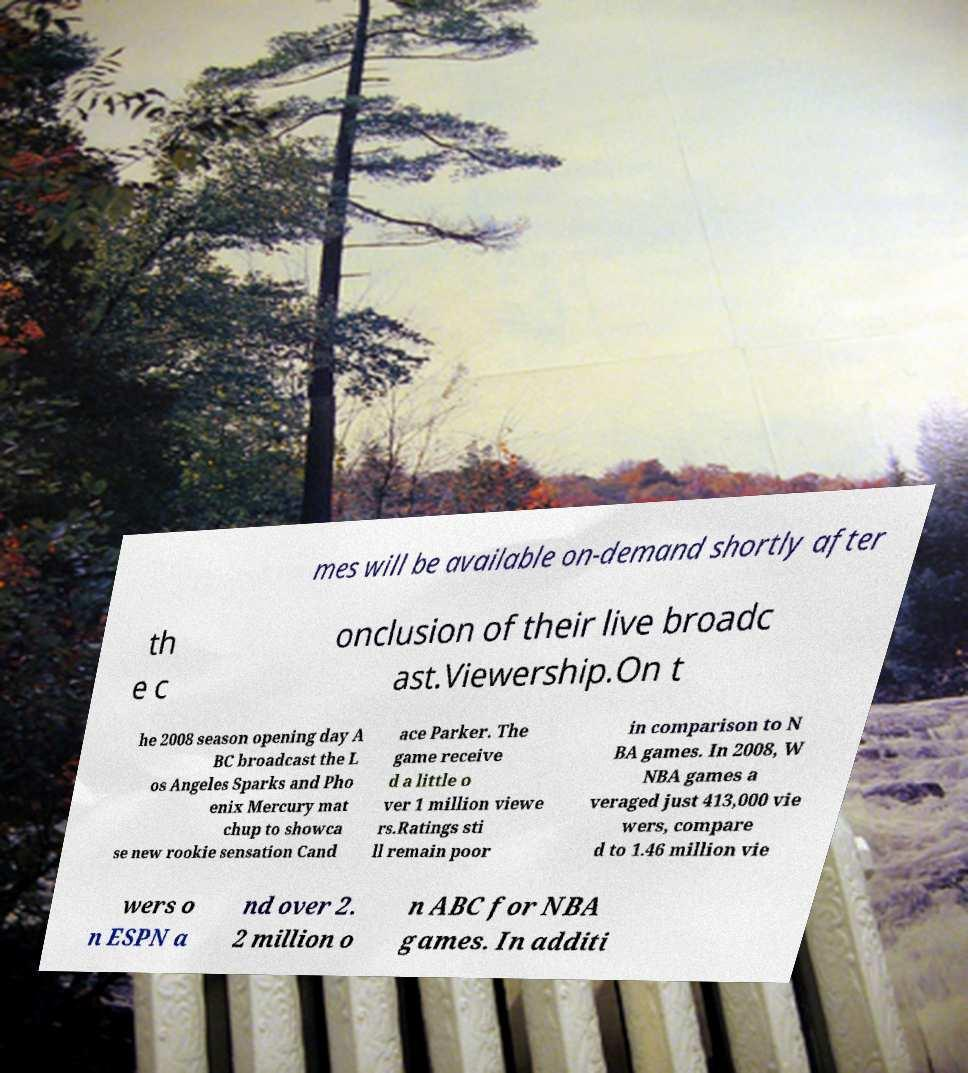What messages or text are displayed in this image? I need them in a readable, typed format. mes will be available on-demand shortly after th e c onclusion of their live broadc ast.Viewership.On t he 2008 season opening day A BC broadcast the L os Angeles Sparks and Pho enix Mercury mat chup to showca se new rookie sensation Cand ace Parker. The game receive d a little o ver 1 million viewe rs.Ratings sti ll remain poor in comparison to N BA games. In 2008, W NBA games a veraged just 413,000 vie wers, compare d to 1.46 million vie wers o n ESPN a nd over 2. 2 million o n ABC for NBA games. In additi 